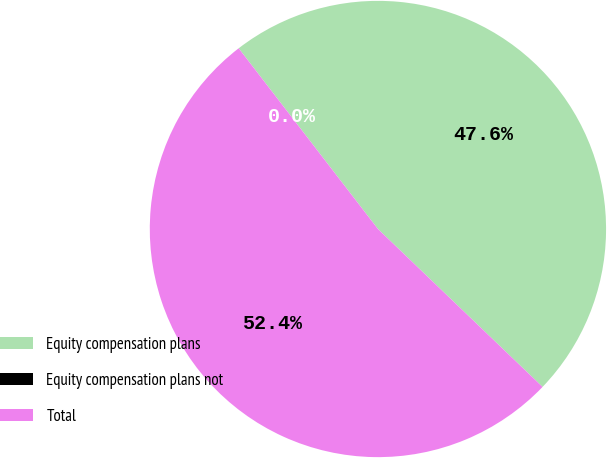<chart> <loc_0><loc_0><loc_500><loc_500><pie_chart><fcel>Equity compensation plans<fcel>Equity compensation plans not<fcel>Total<nl><fcel>47.62%<fcel>0.0%<fcel>52.38%<nl></chart> 